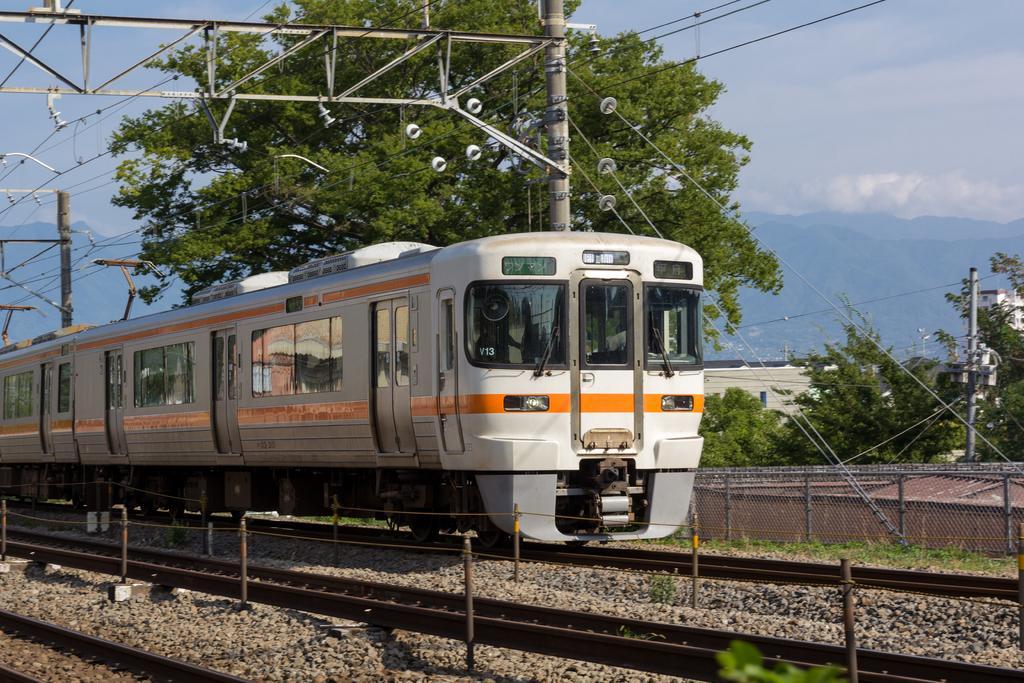How would you summarize this image in a sentence or two? In this picture I can see a train on the railway track. In the background I can see the sky, trees, poles which has wires, grass and other objects. 